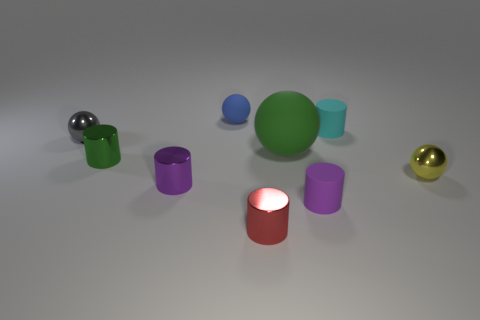Is there any other thing that has the same size as the green ball?
Provide a short and direct response. No. The big rubber object has what color?
Your answer should be very brief. Green. There is a purple object left of the small metallic thing that is in front of the purple object that is on the right side of the tiny red shiny thing; what is its shape?
Your answer should be compact. Cylinder. What number of other things are the same color as the large rubber object?
Offer a terse response. 1. Is the number of cyan cylinders that are in front of the red object greater than the number of small metal objects that are behind the yellow shiny sphere?
Your answer should be very brief. No. Are there any large matte balls in front of the tiny purple metal cylinder?
Provide a short and direct response. No. What is the small cylinder that is left of the purple rubber object and on the right side of the purple metallic thing made of?
Provide a succinct answer. Metal. There is another metallic object that is the same shape as the yellow thing; what is its color?
Ensure brevity in your answer.  Gray. Is there a small green metal thing that is left of the metallic ball that is to the right of the blue thing?
Offer a very short reply. Yes. What is the size of the green shiny cylinder?
Your response must be concise. Small. 